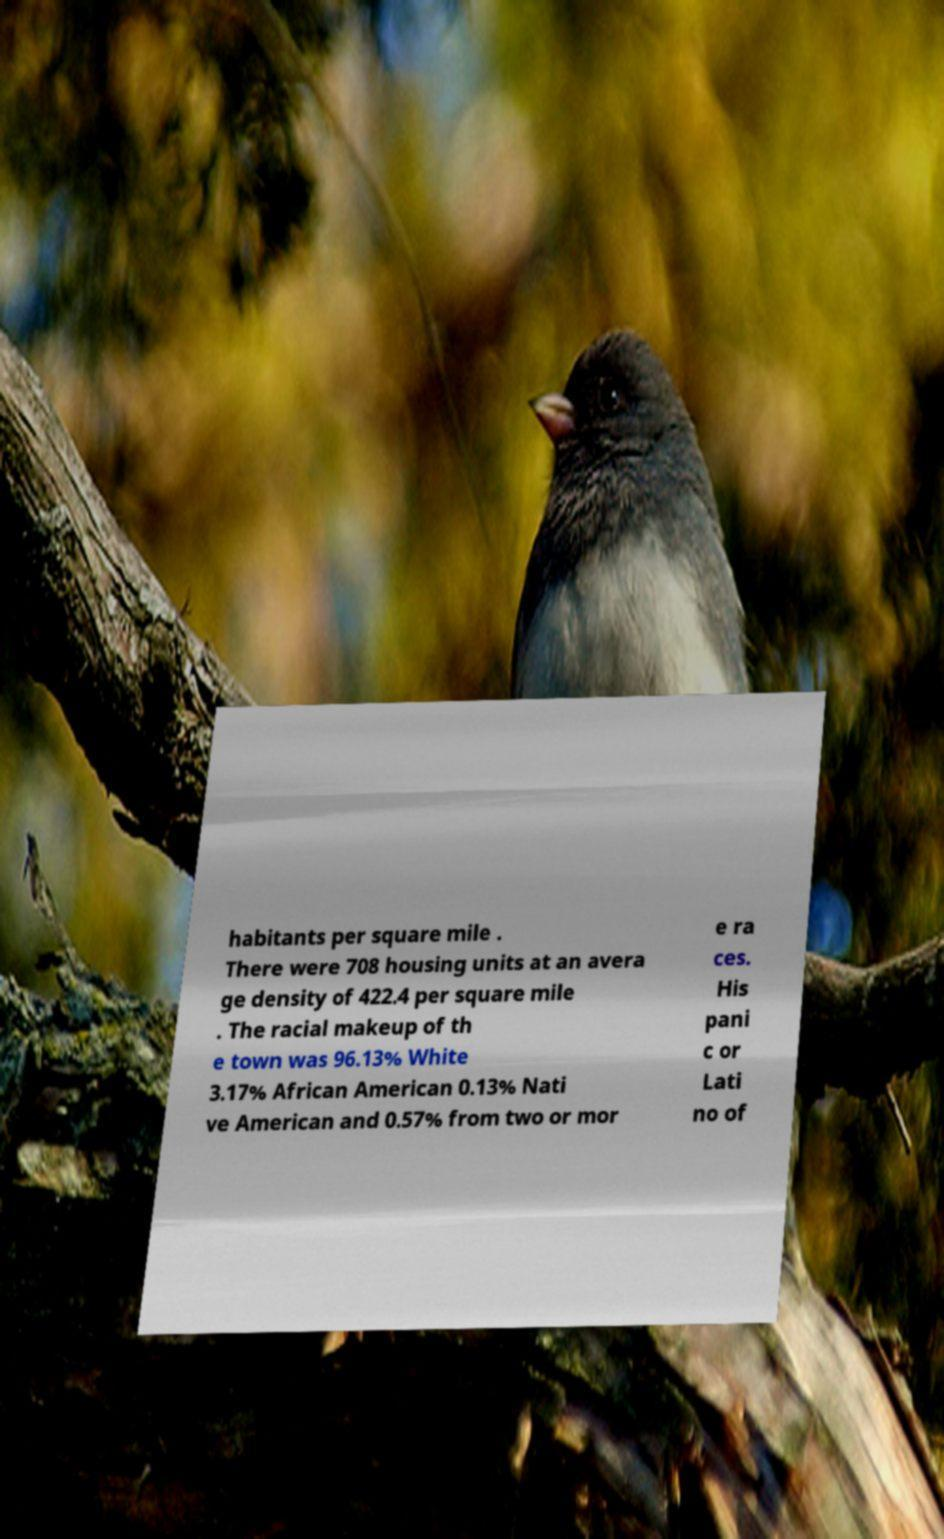Could you assist in decoding the text presented in this image and type it out clearly? habitants per square mile . There were 708 housing units at an avera ge density of 422.4 per square mile . The racial makeup of th e town was 96.13% White 3.17% African American 0.13% Nati ve American and 0.57% from two or mor e ra ces. His pani c or Lati no of 